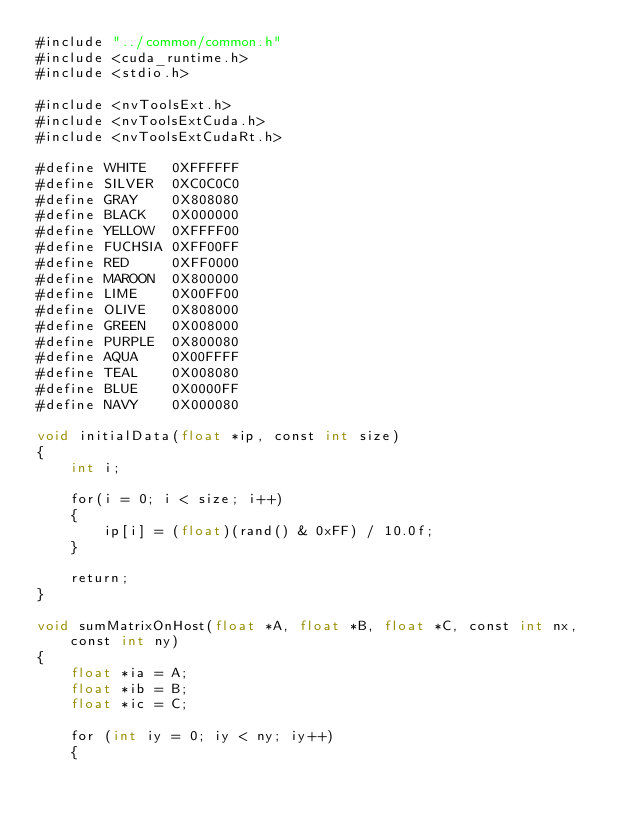Convert code to text. <code><loc_0><loc_0><loc_500><loc_500><_Cuda_>#include "../common/common.h"
#include <cuda_runtime.h>
#include <stdio.h>

#include <nvToolsExt.h>
#include <nvToolsExtCuda.h>
#include <nvToolsExtCudaRt.h>

#define WHITE   0XFFFFFF
#define SILVER  0XC0C0C0
#define GRAY    0X808080
#define BLACK   0X000000
#define YELLOW  0XFFFF00
#define FUCHSIA 0XFF00FF
#define RED     0XFF0000
#define MAROON  0X800000
#define LIME    0X00FF00
#define OLIVE   0X808000
#define GREEN   0X008000
#define PURPLE  0X800080
#define AQUA    0X00FFFF
#define TEAL    0X008080
#define BLUE    0X0000FF
#define NAVY    0X000080

void initialData(float *ip, const int size)
{
    int i;

    for(i = 0; i < size; i++)
    {
        ip[i] = (float)(rand() & 0xFF) / 10.0f;
    }

    return;
}

void sumMatrixOnHost(float *A, float *B, float *C, const int nx, const int ny)
{
    float *ia = A;
    float *ib = B;
    float *ic = C;

    for (int iy = 0; iy < ny; iy++)
    {</code> 